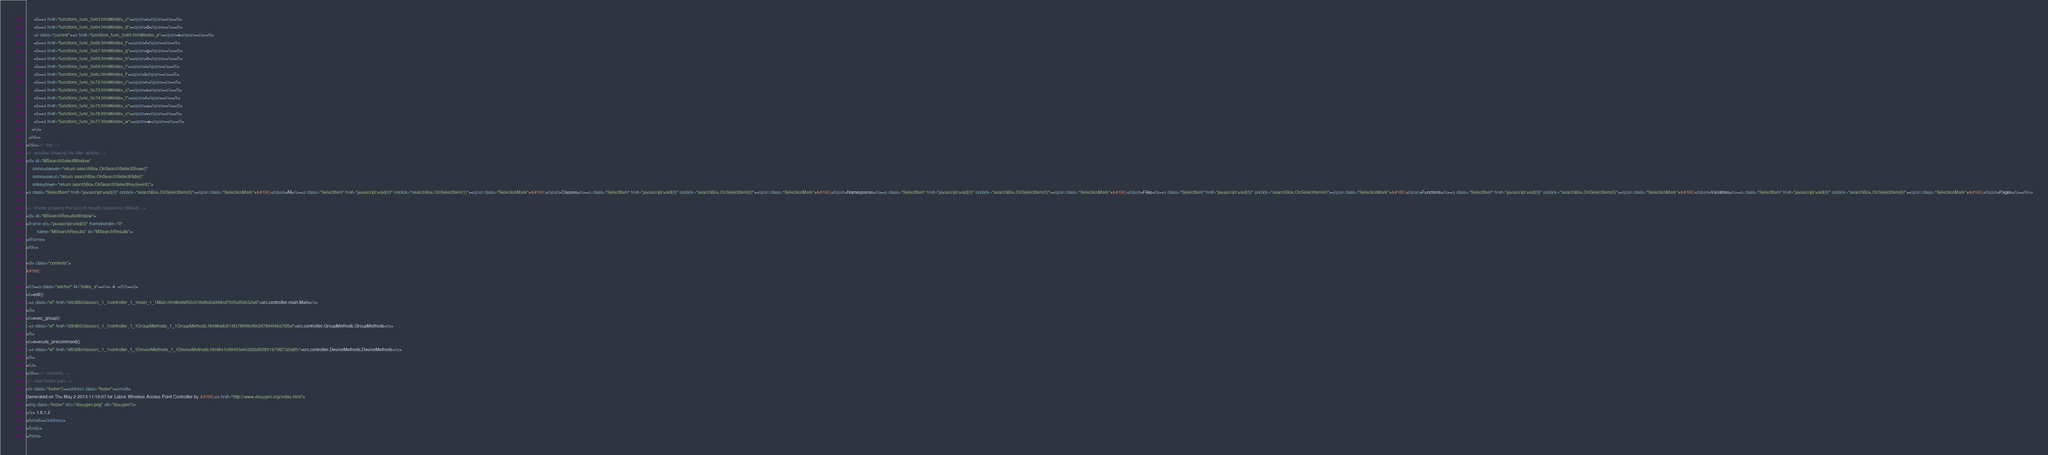<code> <loc_0><loc_0><loc_500><loc_500><_HTML_>      <li><a href="functions_func_0x63.html#index_c"><span>c</span></a></li>
      <li><a href="functions_func_0x64.html#index_d"><span>d</span></a></li>
      <li class="current"><a href="functions_func_0x65.html#index_e"><span>e</span></a></li>
      <li><a href="functions_func_0x66.html#index_f"><span>f</span></a></li>
      <li><a href="functions_func_0x67.html#index_g"><span>g</span></a></li>
      <li><a href="functions_func_0x68.html#index_h"><span>h</span></a></li>
      <li><a href="functions_func_0x69.html#index_i"><span>i</span></a></li>
      <li><a href="functions_func_0x6c.html#index_l"><span>l</span></a></li>
      <li><a href="functions_func_0x72.html#index_r"><span>r</span></a></li>
      <li><a href="functions_func_0x73.html#index_s"><span>s</span></a></li>
      <li><a href="functions_func_0x74.html#index_t"><span>t</span></a></li>
      <li><a href="functions_func_0x75.html#index_u"><span>u</span></a></li>
      <li><a href="functions_func_0x76.html#index_v"><span>v</span></a></li>
      <li><a href="functions_func_0x77.html#index_w"><span>w</span></a></li>
    </ul>
  </div>
</div><!-- top -->
<!-- window showing the filter options -->
<div id="MSearchSelectWindow"
     onmouseover="return searchBox.OnSearchSelectShow()"
     onmouseout="return searchBox.OnSearchSelectHide()"
     onkeydown="return searchBox.OnSearchSelectKey(event)">
<a class="SelectItem" href="javascript:void(0)" onclick="searchBox.OnSelectItem(0)"><span class="SelectionMark">&#160;</span>All</a><a class="SelectItem" href="javascript:void(0)" onclick="searchBox.OnSelectItem(1)"><span class="SelectionMark">&#160;</span>Classes</a><a class="SelectItem" href="javascript:void(0)" onclick="searchBox.OnSelectItem(2)"><span class="SelectionMark">&#160;</span>Namespaces</a><a class="SelectItem" href="javascript:void(0)" onclick="searchBox.OnSelectItem(3)"><span class="SelectionMark">&#160;</span>Files</a><a class="SelectItem" href="javascript:void(0)" onclick="searchBox.OnSelectItem(4)"><span class="SelectionMark">&#160;</span>Functions</a><a class="SelectItem" href="javascript:void(0)" onclick="searchBox.OnSelectItem(5)"><span class="SelectionMark">&#160;</span>Variables</a><a class="SelectItem" href="javascript:void(0)" onclick="searchBox.OnSelectItem(6)"><span class="SelectionMark">&#160;</span>Pages</a></div>

<!-- iframe showing the search results (closed by default) -->
<div id="MSearchResultsWindow">
<iframe src="javascript:void(0)" frameborder="0" 
        name="MSearchResults" id="MSearchResults">
</iframe>
</div>

<div class="contents">
&#160;

<h3><a class="anchor" id="index_e"></a>- e -</h3><ul>
<li>edit()
: <a class="el" href="d4/d2b/classsrc_1_1controller_1_1main_1_1Main.html#a9ef55c016d8e2ad48cd7035af5dc52a6">src.controller.main.Main</a>
</li>
<li>exec_group()
: <a class="el" href="d9/db5/classsrc_1_1controller_1_1GroupMethods_1_1GroupMethods.html#adc814f378f4f9c89cbf7894f46a7f2bd">src.controller.GroupMethods.GroupMethods</a>
</li>
<li>execute_precommand()
: <a class="el" href="d8/ddb/classsrc_1_1controller_1_1DeviceMethods_1_1DeviceMethods.html#a1c68455e4c02daf00831679f27a5a8fc">src.controller.DeviceMethods.DeviceMethods</a>
</li>
</ul>
</div><!-- contents -->
<!-- start footer part -->
<hr class="footer"/><address class="footer"><small>
Generated on Thu May 2 2013 11:19:07 for Labris Wireless Access Point Controller by &#160;<a href="http://www.doxygen.org/index.html">
<img class="footer" src="doxygen.png" alt="doxygen"/>
</a> 1.8.1.2
</small></address>
</body>
</html>
</code> 